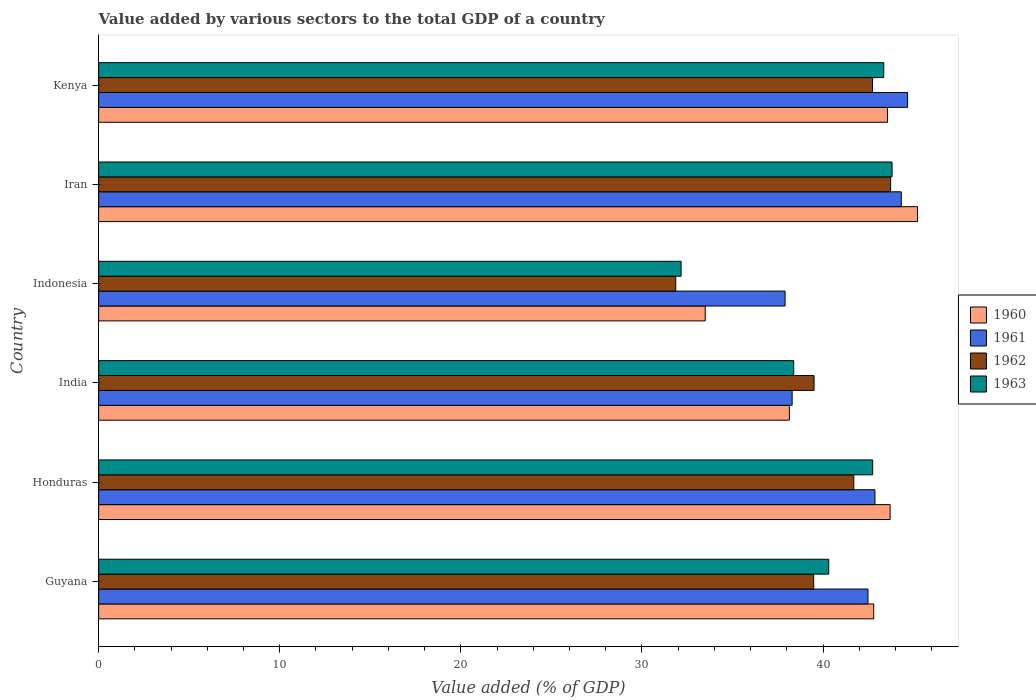How many different coloured bars are there?
Your answer should be very brief. 4. How many groups of bars are there?
Give a very brief answer. 6. Are the number of bars on each tick of the Y-axis equal?
Provide a short and direct response. Yes. How many bars are there on the 1st tick from the top?
Your answer should be compact. 4. How many bars are there on the 3rd tick from the bottom?
Your answer should be compact. 4. What is the label of the 4th group of bars from the top?
Your response must be concise. India. What is the value added by various sectors to the total GDP in 1961 in Iran?
Your response must be concise. 44.32. Across all countries, what is the maximum value added by various sectors to the total GDP in 1963?
Your response must be concise. 43.81. Across all countries, what is the minimum value added by various sectors to the total GDP in 1960?
Offer a terse response. 33.5. In which country was the value added by various sectors to the total GDP in 1960 maximum?
Make the answer very short. Iran. In which country was the value added by various sectors to the total GDP in 1961 minimum?
Provide a short and direct response. Indonesia. What is the total value added by various sectors to the total GDP in 1963 in the graph?
Give a very brief answer. 240.76. What is the difference between the value added by various sectors to the total GDP in 1963 in India and that in Indonesia?
Your answer should be compact. 6.22. What is the difference between the value added by various sectors to the total GDP in 1960 in Kenya and the value added by various sectors to the total GDP in 1963 in Indonesia?
Make the answer very short. 11.4. What is the average value added by various sectors to the total GDP in 1962 per country?
Ensure brevity in your answer.  39.84. What is the difference between the value added by various sectors to the total GDP in 1962 and value added by various sectors to the total GDP in 1960 in Iran?
Provide a succinct answer. -1.48. What is the ratio of the value added by various sectors to the total GDP in 1963 in Guyana to that in Kenya?
Offer a very short reply. 0.93. Is the difference between the value added by various sectors to the total GDP in 1962 in Guyana and Kenya greater than the difference between the value added by various sectors to the total GDP in 1960 in Guyana and Kenya?
Provide a short and direct response. No. What is the difference between the highest and the second highest value added by various sectors to the total GDP in 1961?
Offer a very short reply. 0.35. What is the difference between the highest and the lowest value added by various sectors to the total GDP in 1960?
Your answer should be very brief. 11.72. Is the sum of the value added by various sectors to the total GDP in 1962 in Guyana and Honduras greater than the maximum value added by various sectors to the total GDP in 1960 across all countries?
Your response must be concise. Yes. Is it the case that in every country, the sum of the value added by various sectors to the total GDP in 1961 and value added by various sectors to the total GDP in 1962 is greater than the sum of value added by various sectors to the total GDP in 1963 and value added by various sectors to the total GDP in 1960?
Give a very brief answer. No. What does the 2nd bar from the top in India represents?
Provide a succinct answer. 1962. How many bars are there?
Make the answer very short. 24. Are all the bars in the graph horizontal?
Offer a very short reply. Yes. How many countries are there in the graph?
Offer a terse response. 6. What is the difference between two consecutive major ticks on the X-axis?
Your answer should be compact. 10. Does the graph contain any zero values?
Ensure brevity in your answer.  No. Does the graph contain grids?
Provide a succinct answer. No. How many legend labels are there?
Provide a short and direct response. 4. What is the title of the graph?
Make the answer very short. Value added by various sectors to the total GDP of a country. Does "2004" appear as one of the legend labels in the graph?
Offer a terse response. No. What is the label or title of the X-axis?
Ensure brevity in your answer.  Value added (% of GDP). What is the label or title of the Y-axis?
Your answer should be very brief. Country. What is the Value added (% of GDP) in 1960 in Guyana?
Ensure brevity in your answer.  42.8. What is the Value added (% of GDP) in 1961 in Guyana?
Provide a short and direct response. 42.48. What is the Value added (% of GDP) in 1962 in Guyana?
Make the answer very short. 39.48. What is the Value added (% of GDP) in 1963 in Guyana?
Ensure brevity in your answer.  40.31. What is the Value added (% of GDP) in 1960 in Honduras?
Make the answer very short. 43.7. What is the Value added (% of GDP) in 1961 in Honduras?
Keep it short and to the point. 42.86. What is the Value added (% of GDP) of 1962 in Honduras?
Keep it short and to the point. 41.7. What is the Value added (% of GDP) in 1963 in Honduras?
Give a very brief answer. 42.74. What is the Value added (% of GDP) in 1960 in India?
Your answer should be very brief. 38.14. What is the Value added (% of GDP) in 1961 in India?
Make the answer very short. 38.29. What is the Value added (% of GDP) in 1962 in India?
Make the answer very short. 39.5. What is the Value added (% of GDP) in 1963 in India?
Provide a succinct answer. 38.38. What is the Value added (% of GDP) of 1960 in Indonesia?
Ensure brevity in your answer.  33.5. What is the Value added (% of GDP) of 1961 in Indonesia?
Your response must be concise. 37.9. What is the Value added (% of GDP) in 1962 in Indonesia?
Your answer should be compact. 31.87. What is the Value added (% of GDP) of 1963 in Indonesia?
Keep it short and to the point. 32.16. What is the Value added (% of GDP) of 1960 in Iran?
Your answer should be very brief. 45.21. What is the Value added (% of GDP) of 1961 in Iran?
Your answer should be very brief. 44.32. What is the Value added (% of GDP) in 1962 in Iran?
Make the answer very short. 43.73. What is the Value added (% of GDP) of 1963 in Iran?
Provide a succinct answer. 43.81. What is the Value added (% of GDP) of 1960 in Kenya?
Provide a short and direct response. 43.56. What is the Value added (% of GDP) of 1961 in Kenya?
Give a very brief answer. 44.67. What is the Value added (% of GDP) of 1962 in Kenya?
Keep it short and to the point. 42.73. What is the Value added (% of GDP) of 1963 in Kenya?
Your answer should be very brief. 43.35. Across all countries, what is the maximum Value added (% of GDP) in 1960?
Keep it short and to the point. 45.21. Across all countries, what is the maximum Value added (% of GDP) in 1961?
Your answer should be compact. 44.67. Across all countries, what is the maximum Value added (% of GDP) of 1962?
Offer a terse response. 43.73. Across all countries, what is the maximum Value added (% of GDP) in 1963?
Offer a very short reply. 43.81. Across all countries, what is the minimum Value added (% of GDP) in 1960?
Offer a very short reply. 33.5. Across all countries, what is the minimum Value added (% of GDP) in 1961?
Offer a terse response. 37.9. Across all countries, what is the minimum Value added (% of GDP) of 1962?
Your answer should be very brief. 31.87. Across all countries, what is the minimum Value added (% of GDP) of 1963?
Make the answer very short. 32.16. What is the total Value added (% of GDP) of 1960 in the graph?
Your response must be concise. 246.91. What is the total Value added (% of GDP) of 1961 in the graph?
Give a very brief answer. 250.53. What is the total Value added (% of GDP) in 1962 in the graph?
Provide a succinct answer. 239.01. What is the total Value added (% of GDP) in 1963 in the graph?
Ensure brevity in your answer.  240.76. What is the difference between the Value added (% of GDP) of 1960 in Guyana and that in Honduras?
Give a very brief answer. -0.91. What is the difference between the Value added (% of GDP) of 1961 in Guyana and that in Honduras?
Ensure brevity in your answer.  -0.38. What is the difference between the Value added (% of GDP) of 1962 in Guyana and that in Honduras?
Your response must be concise. -2.21. What is the difference between the Value added (% of GDP) of 1963 in Guyana and that in Honduras?
Your answer should be compact. -2.43. What is the difference between the Value added (% of GDP) in 1960 in Guyana and that in India?
Provide a succinct answer. 4.66. What is the difference between the Value added (% of GDP) in 1961 in Guyana and that in India?
Ensure brevity in your answer.  4.19. What is the difference between the Value added (% of GDP) of 1962 in Guyana and that in India?
Give a very brief answer. -0.02. What is the difference between the Value added (% of GDP) of 1963 in Guyana and that in India?
Make the answer very short. 1.93. What is the difference between the Value added (% of GDP) in 1960 in Guyana and that in Indonesia?
Your answer should be very brief. 9.3. What is the difference between the Value added (% of GDP) of 1961 in Guyana and that in Indonesia?
Give a very brief answer. 4.58. What is the difference between the Value added (% of GDP) of 1962 in Guyana and that in Indonesia?
Make the answer very short. 7.62. What is the difference between the Value added (% of GDP) in 1963 in Guyana and that in Indonesia?
Offer a very short reply. 8.15. What is the difference between the Value added (% of GDP) of 1960 in Guyana and that in Iran?
Make the answer very short. -2.42. What is the difference between the Value added (% of GDP) of 1961 in Guyana and that in Iran?
Offer a terse response. -1.84. What is the difference between the Value added (% of GDP) of 1962 in Guyana and that in Iran?
Your answer should be very brief. -4.25. What is the difference between the Value added (% of GDP) of 1963 in Guyana and that in Iran?
Provide a short and direct response. -3.5. What is the difference between the Value added (% of GDP) in 1960 in Guyana and that in Kenya?
Provide a succinct answer. -0.76. What is the difference between the Value added (% of GDP) in 1961 in Guyana and that in Kenya?
Provide a short and direct response. -2.19. What is the difference between the Value added (% of GDP) in 1962 in Guyana and that in Kenya?
Your answer should be very brief. -3.25. What is the difference between the Value added (% of GDP) of 1963 in Guyana and that in Kenya?
Offer a very short reply. -3.04. What is the difference between the Value added (% of GDP) of 1960 in Honduras and that in India?
Offer a very short reply. 5.57. What is the difference between the Value added (% of GDP) of 1961 in Honduras and that in India?
Provide a succinct answer. 4.57. What is the difference between the Value added (% of GDP) of 1962 in Honduras and that in India?
Your response must be concise. 2.19. What is the difference between the Value added (% of GDP) of 1963 in Honduras and that in India?
Provide a succinct answer. 4.36. What is the difference between the Value added (% of GDP) in 1960 in Honduras and that in Indonesia?
Keep it short and to the point. 10.21. What is the difference between the Value added (% of GDP) in 1961 in Honduras and that in Indonesia?
Ensure brevity in your answer.  4.96. What is the difference between the Value added (% of GDP) in 1962 in Honduras and that in Indonesia?
Make the answer very short. 9.83. What is the difference between the Value added (% of GDP) of 1963 in Honduras and that in Indonesia?
Offer a terse response. 10.58. What is the difference between the Value added (% of GDP) in 1960 in Honduras and that in Iran?
Offer a very short reply. -1.51. What is the difference between the Value added (% of GDP) of 1961 in Honduras and that in Iran?
Offer a terse response. -1.46. What is the difference between the Value added (% of GDP) of 1962 in Honduras and that in Iran?
Your answer should be compact. -2.03. What is the difference between the Value added (% of GDP) in 1963 in Honduras and that in Iran?
Your answer should be compact. -1.07. What is the difference between the Value added (% of GDP) of 1960 in Honduras and that in Kenya?
Provide a succinct answer. 0.15. What is the difference between the Value added (% of GDP) of 1961 in Honduras and that in Kenya?
Your answer should be very brief. -1.8. What is the difference between the Value added (% of GDP) of 1962 in Honduras and that in Kenya?
Provide a short and direct response. -1.03. What is the difference between the Value added (% of GDP) in 1963 in Honduras and that in Kenya?
Your answer should be compact. -0.61. What is the difference between the Value added (% of GDP) in 1960 in India and that in Indonesia?
Your answer should be very brief. 4.64. What is the difference between the Value added (% of GDP) in 1961 in India and that in Indonesia?
Make the answer very short. 0.39. What is the difference between the Value added (% of GDP) of 1962 in India and that in Indonesia?
Make the answer very short. 7.64. What is the difference between the Value added (% of GDP) of 1963 in India and that in Indonesia?
Your response must be concise. 6.22. What is the difference between the Value added (% of GDP) in 1960 in India and that in Iran?
Your answer should be very brief. -7.08. What is the difference between the Value added (% of GDP) of 1961 in India and that in Iran?
Provide a short and direct response. -6.03. What is the difference between the Value added (% of GDP) of 1962 in India and that in Iran?
Keep it short and to the point. -4.23. What is the difference between the Value added (% of GDP) in 1963 in India and that in Iran?
Offer a terse response. -5.43. What is the difference between the Value added (% of GDP) in 1960 in India and that in Kenya?
Ensure brevity in your answer.  -5.42. What is the difference between the Value added (% of GDP) in 1961 in India and that in Kenya?
Keep it short and to the point. -6.37. What is the difference between the Value added (% of GDP) of 1962 in India and that in Kenya?
Keep it short and to the point. -3.23. What is the difference between the Value added (% of GDP) in 1963 in India and that in Kenya?
Provide a succinct answer. -4.97. What is the difference between the Value added (% of GDP) of 1960 in Indonesia and that in Iran?
Provide a short and direct response. -11.72. What is the difference between the Value added (% of GDP) in 1961 in Indonesia and that in Iran?
Your answer should be compact. -6.42. What is the difference between the Value added (% of GDP) in 1962 in Indonesia and that in Iran?
Provide a succinct answer. -11.86. What is the difference between the Value added (% of GDP) in 1963 in Indonesia and that in Iran?
Your answer should be compact. -11.65. What is the difference between the Value added (% of GDP) in 1960 in Indonesia and that in Kenya?
Ensure brevity in your answer.  -10.06. What is the difference between the Value added (% of GDP) in 1961 in Indonesia and that in Kenya?
Make the answer very short. -6.76. What is the difference between the Value added (% of GDP) in 1962 in Indonesia and that in Kenya?
Offer a terse response. -10.87. What is the difference between the Value added (% of GDP) of 1963 in Indonesia and that in Kenya?
Keep it short and to the point. -11.19. What is the difference between the Value added (% of GDP) in 1960 in Iran and that in Kenya?
Ensure brevity in your answer.  1.65. What is the difference between the Value added (% of GDP) of 1961 in Iran and that in Kenya?
Provide a succinct answer. -0.35. What is the difference between the Value added (% of GDP) of 1962 in Iran and that in Kenya?
Ensure brevity in your answer.  1. What is the difference between the Value added (% of GDP) of 1963 in Iran and that in Kenya?
Your answer should be very brief. 0.46. What is the difference between the Value added (% of GDP) of 1960 in Guyana and the Value added (% of GDP) of 1961 in Honduras?
Your response must be concise. -0.07. What is the difference between the Value added (% of GDP) of 1960 in Guyana and the Value added (% of GDP) of 1962 in Honduras?
Ensure brevity in your answer.  1.1. What is the difference between the Value added (% of GDP) of 1960 in Guyana and the Value added (% of GDP) of 1963 in Honduras?
Provide a succinct answer. 0.06. What is the difference between the Value added (% of GDP) in 1961 in Guyana and the Value added (% of GDP) in 1962 in Honduras?
Your answer should be compact. 0.78. What is the difference between the Value added (% of GDP) of 1961 in Guyana and the Value added (% of GDP) of 1963 in Honduras?
Ensure brevity in your answer.  -0.26. What is the difference between the Value added (% of GDP) of 1962 in Guyana and the Value added (% of GDP) of 1963 in Honduras?
Give a very brief answer. -3.26. What is the difference between the Value added (% of GDP) in 1960 in Guyana and the Value added (% of GDP) in 1961 in India?
Your answer should be very brief. 4.5. What is the difference between the Value added (% of GDP) in 1960 in Guyana and the Value added (% of GDP) in 1962 in India?
Offer a very short reply. 3.29. What is the difference between the Value added (% of GDP) of 1960 in Guyana and the Value added (% of GDP) of 1963 in India?
Make the answer very short. 4.42. What is the difference between the Value added (% of GDP) in 1961 in Guyana and the Value added (% of GDP) in 1962 in India?
Your answer should be compact. 2.98. What is the difference between the Value added (% of GDP) in 1961 in Guyana and the Value added (% of GDP) in 1963 in India?
Your answer should be very brief. 4.1. What is the difference between the Value added (% of GDP) in 1962 in Guyana and the Value added (% of GDP) in 1963 in India?
Make the answer very short. 1.1. What is the difference between the Value added (% of GDP) of 1960 in Guyana and the Value added (% of GDP) of 1961 in Indonesia?
Give a very brief answer. 4.89. What is the difference between the Value added (% of GDP) of 1960 in Guyana and the Value added (% of GDP) of 1962 in Indonesia?
Make the answer very short. 10.93. What is the difference between the Value added (% of GDP) in 1960 in Guyana and the Value added (% of GDP) in 1963 in Indonesia?
Your answer should be very brief. 10.64. What is the difference between the Value added (% of GDP) in 1961 in Guyana and the Value added (% of GDP) in 1962 in Indonesia?
Your answer should be compact. 10.61. What is the difference between the Value added (% of GDP) in 1961 in Guyana and the Value added (% of GDP) in 1963 in Indonesia?
Your response must be concise. 10.32. What is the difference between the Value added (% of GDP) in 1962 in Guyana and the Value added (% of GDP) in 1963 in Indonesia?
Your answer should be compact. 7.32. What is the difference between the Value added (% of GDP) of 1960 in Guyana and the Value added (% of GDP) of 1961 in Iran?
Keep it short and to the point. -1.52. What is the difference between the Value added (% of GDP) in 1960 in Guyana and the Value added (% of GDP) in 1962 in Iran?
Give a very brief answer. -0.93. What is the difference between the Value added (% of GDP) of 1960 in Guyana and the Value added (% of GDP) of 1963 in Iran?
Provide a succinct answer. -1.01. What is the difference between the Value added (% of GDP) of 1961 in Guyana and the Value added (% of GDP) of 1962 in Iran?
Make the answer very short. -1.25. What is the difference between the Value added (% of GDP) of 1961 in Guyana and the Value added (% of GDP) of 1963 in Iran?
Offer a very short reply. -1.33. What is the difference between the Value added (% of GDP) in 1962 in Guyana and the Value added (% of GDP) in 1963 in Iran?
Make the answer very short. -4.33. What is the difference between the Value added (% of GDP) of 1960 in Guyana and the Value added (% of GDP) of 1961 in Kenya?
Your answer should be very brief. -1.87. What is the difference between the Value added (% of GDP) in 1960 in Guyana and the Value added (% of GDP) in 1962 in Kenya?
Provide a short and direct response. 0.07. What is the difference between the Value added (% of GDP) of 1960 in Guyana and the Value added (% of GDP) of 1963 in Kenya?
Ensure brevity in your answer.  -0.55. What is the difference between the Value added (% of GDP) in 1961 in Guyana and the Value added (% of GDP) in 1962 in Kenya?
Provide a succinct answer. -0.25. What is the difference between the Value added (% of GDP) of 1961 in Guyana and the Value added (% of GDP) of 1963 in Kenya?
Your answer should be very brief. -0.87. What is the difference between the Value added (% of GDP) in 1962 in Guyana and the Value added (% of GDP) in 1963 in Kenya?
Your answer should be very brief. -3.87. What is the difference between the Value added (% of GDP) of 1960 in Honduras and the Value added (% of GDP) of 1961 in India?
Keep it short and to the point. 5.41. What is the difference between the Value added (% of GDP) of 1960 in Honduras and the Value added (% of GDP) of 1962 in India?
Offer a terse response. 4.2. What is the difference between the Value added (% of GDP) in 1960 in Honduras and the Value added (% of GDP) in 1963 in India?
Your answer should be very brief. 5.32. What is the difference between the Value added (% of GDP) of 1961 in Honduras and the Value added (% of GDP) of 1962 in India?
Make the answer very short. 3.36. What is the difference between the Value added (% of GDP) of 1961 in Honduras and the Value added (% of GDP) of 1963 in India?
Your response must be concise. 4.48. What is the difference between the Value added (% of GDP) in 1962 in Honduras and the Value added (% of GDP) in 1963 in India?
Provide a short and direct response. 3.32. What is the difference between the Value added (% of GDP) in 1960 in Honduras and the Value added (% of GDP) in 1961 in Indonesia?
Your response must be concise. 5.8. What is the difference between the Value added (% of GDP) of 1960 in Honduras and the Value added (% of GDP) of 1962 in Indonesia?
Your answer should be compact. 11.84. What is the difference between the Value added (% of GDP) in 1960 in Honduras and the Value added (% of GDP) in 1963 in Indonesia?
Your answer should be very brief. 11.54. What is the difference between the Value added (% of GDP) of 1961 in Honduras and the Value added (% of GDP) of 1962 in Indonesia?
Your response must be concise. 11. What is the difference between the Value added (% of GDP) in 1961 in Honduras and the Value added (% of GDP) in 1963 in Indonesia?
Offer a terse response. 10.7. What is the difference between the Value added (% of GDP) of 1962 in Honduras and the Value added (% of GDP) of 1963 in Indonesia?
Ensure brevity in your answer.  9.54. What is the difference between the Value added (% of GDP) in 1960 in Honduras and the Value added (% of GDP) in 1961 in Iran?
Make the answer very short. -0.62. What is the difference between the Value added (% of GDP) in 1960 in Honduras and the Value added (% of GDP) in 1962 in Iran?
Provide a short and direct response. -0.03. What is the difference between the Value added (% of GDP) of 1960 in Honduras and the Value added (% of GDP) of 1963 in Iran?
Your answer should be compact. -0.11. What is the difference between the Value added (% of GDP) in 1961 in Honduras and the Value added (% of GDP) in 1962 in Iran?
Give a very brief answer. -0.87. What is the difference between the Value added (% of GDP) in 1961 in Honduras and the Value added (% of GDP) in 1963 in Iran?
Your answer should be very brief. -0.95. What is the difference between the Value added (% of GDP) in 1962 in Honduras and the Value added (% of GDP) in 1963 in Iran?
Offer a very short reply. -2.11. What is the difference between the Value added (% of GDP) in 1960 in Honduras and the Value added (% of GDP) in 1961 in Kenya?
Ensure brevity in your answer.  -0.96. What is the difference between the Value added (% of GDP) of 1960 in Honduras and the Value added (% of GDP) of 1962 in Kenya?
Ensure brevity in your answer.  0.97. What is the difference between the Value added (% of GDP) in 1960 in Honduras and the Value added (% of GDP) in 1963 in Kenya?
Your answer should be very brief. 0.35. What is the difference between the Value added (% of GDP) of 1961 in Honduras and the Value added (% of GDP) of 1962 in Kenya?
Your answer should be very brief. 0.13. What is the difference between the Value added (% of GDP) of 1961 in Honduras and the Value added (% of GDP) of 1963 in Kenya?
Offer a very short reply. -0.49. What is the difference between the Value added (% of GDP) in 1962 in Honduras and the Value added (% of GDP) in 1963 in Kenya?
Provide a succinct answer. -1.65. What is the difference between the Value added (% of GDP) of 1960 in India and the Value added (% of GDP) of 1961 in Indonesia?
Your answer should be very brief. 0.24. What is the difference between the Value added (% of GDP) in 1960 in India and the Value added (% of GDP) in 1962 in Indonesia?
Your answer should be compact. 6.27. What is the difference between the Value added (% of GDP) of 1960 in India and the Value added (% of GDP) of 1963 in Indonesia?
Your response must be concise. 5.98. What is the difference between the Value added (% of GDP) of 1961 in India and the Value added (% of GDP) of 1962 in Indonesia?
Offer a very short reply. 6.43. What is the difference between the Value added (% of GDP) of 1961 in India and the Value added (% of GDP) of 1963 in Indonesia?
Offer a terse response. 6.13. What is the difference between the Value added (% of GDP) of 1962 in India and the Value added (% of GDP) of 1963 in Indonesia?
Give a very brief answer. 7.34. What is the difference between the Value added (% of GDP) of 1960 in India and the Value added (% of GDP) of 1961 in Iran?
Ensure brevity in your answer.  -6.18. What is the difference between the Value added (% of GDP) of 1960 in India and the Value added (% of GDP) of 1962 in Iran?
Provide a short and direct response. -5.59. What is the difference between the Value added (% of GDP) of 1960 in India and the Value added (% of GDP) of 1963 in Iran?
Provide a succinct answer. -5.67. What is the difference between the Value added (% of GDP) of 1961 in India and the Value added (% of GDP) of 1962 in Iran?
Keep it short and to the point. -5.44. What is the difference between the Value added (% of GDP) in 1961 in India and the Value added (% of GDP) in 1963 in Iran?
Provide a succinct answer. -5.52. What is the difference between the Value added (% of GDP) of 1962 in India and the Value added (% of GDP) of 1963 in Iran?
Give a very brief answer. -4.31. What is the difference between the Value added (% of GDP) in 1960 in India and the Value added (% of GDP) in 1961 in Kenya?
Provide a short and direct response. -6.53. What is the difference between the Value added (% of GDP) in 1960 in India and the Value added (% of GDP) in 1962 in Kenya?
Make the answer very short. -4.59. What is the difference between the Value added (% of GDP) in 1960 in India and the Value added (% of GDP) in 1963 in Kenya?
Make the answer very short. -5.21. What is the difference between the Value added (% of GDP) in 1961 in India and the Value added (% of GDP) in 1962 in Kenya?
Offer a terse response. -4.44. What is the difference between the Value added (% of GDP) in 1961 in India and the Value added (% of GDP) in 1963 in Kenya?
Keep it short and to the point. -5.06. What is the difference between the Value added (% of GDP) in 1962 in India and the Value added (% of GDP) in 1963 in Kenya?
Your answer should be compact. -3.85. What is the difference between the Value added (% of GDP) of 1960 in Indonesia and the Value added (% of GDP) of 1961 in Iran?
Offer a very short reply. -10.82. What is the difference between the Value added (% of GDP) in 1960 in Indonesia and the Value added (% of GDP) in 1962 in Iran?
Your answer should be compact. -10.24. What is the difference between the Value added (% of GDP) of 1960 in Indonesia and the Value added (% of GDP) of 1963 in Iran?
Provide a short and direct response. -10.32. What is the difference between the Value added (% of GDP) in 1961 in Indonesia and the Value added (% of GDP) in 1962 in Iran?
Provide a succinct answer. -5.83. What is the difference between the Value added (% of GDP) in 1961 in Indonesia and the Value added (% of GDP) in 1963 in Iran?
Your response must be concise. -5.91. What is the difference between the Value added (% of GDP) in 1962 in Indonesia and the Value added (% of GDP) in 1963 in Iran?
Your answer should be very brief. -11.94. What is the difference between the Value added (% of GDP) of 1960 in Indonesia and the Value added (% of GDP) of 1961 in Kenya?
Your answer should be compact. -11.17. What is the difference between the Value added (% of GDP) of 1960 in Indonesia and the Value added (% of GDP) of 1962 in Kenya?
Offer a terse response. -9.24. What is the difference between the Value added (% of GDP) in 1960 in Indonesia and the Value added (% of GDP) in 1963 in Kenya?
Offer a terse response. -9.86. What is the difference between the Value added (% of GDP) in 1961 in Indonesia and the Value added (% of GDP) in 1962 in Kenya?
Your response must be concise. -4.83. What is the difference between the Value added (% of GDP) of 1961 in Indonesia and the Value added (% of GDP) of 1963 in Kenya?
Make the answer very short. -5.45. What is the difference between the Value added (% of GDP) of 1962 in Indonesia and the Value added (% of GDP) of 1963 in Kenya?
Offer a terse response. -11.48. What is the difference between the Value added (% of GDP) of 1960 in Iran and the Value added (% of GDP) of 1961 in Kenya?
Make the answer very short. 0.55. What is the difference between the Value added (% of GDP) of 1960 in Iran and the Value added (% of GDP) of 1962 in Kenya?
Give a very brief answer. 2.48. What is the difference between the Value added (% of GDP) in 1960 in Iran and the Value added (% of GDP) in 1963 in Kenya?
Keep it short and to the point. 1.86. What is the difference between the Value added (% of GDP) of 1961 in Iran and the Value added (% of GDP) of 1962 in Kenya?
Your response must be concise. 1.59. What is the difference between the Value added (% of GDP) of 1961 in Iran and the Value added (% of GDP) of 1963 in Kenya?
Your answer should be very brief. 0.97. What is the difference between the Value added (% of GDP) of 1962 in Iran and the Value added (% of GDP) of 1963 in Kenya?
Your response must be concise. 0.38. What is the average Value added (% of GDP) in 1960 per country?
Keep it short and to the point. 41.15. What is the average Value added (% of GDP) of 1961 per country?
Offer a very short reply. 41.75. What is the average Value added (% of GDP) in 1962 per country?
Make the answer very short. 39.84. What is the average Value added (% of GDP) in 1963 per country?
Your answer should be very brief. 40.13. What is the difference between the Value added (% of GDP) of 1960 and Value added (% of GDP) of 1961 in Guyana?
Ensure brevity in your answer.  0.32. What is the difference between the Value added (% of GDP) of 1960 and Value added (% of GDP) of 1962 in Guyana?
Make the answer very short. 3.31. What is the difference between the Value added (% of GDP) in 1960 and Value added (% of GDP) in 1963 in Guyana?
Ensure brevity in your answer.  2.48. What is the difference between the Value added (% of GDP) of 1961 and Value added (% of GDP) of 1962 in Guyana?
Give a very brief answer. 3. What is the difference between the Value added (% of GDP) of 1961 and Value added (% of GDP) of 1963 in Guyana?
Make the answer very short. 2.17. What is the difference between the Value added (% of GDP) of 1962 and Value added (% of GDP) of 1963 in Guyana?
Offer a very short reply. -0.83. What is the difference between the Value added (% of GDP) in 1960 and Value added (% of GDP) in 1961 in Honduras?
Offer a terse response. 0.84. What is the difference between the Value added (% of GDP) in 1960 and Value added (% of GDP) in 1962 in Honduras?
Your answer should be compact. 2.01. What is the difference between the Value added (% of GDP) of 1960 and Value added (% of GDP) of 1963 in Honduras?
Keep it short and to the point. 0.96. What is the difference between the Value added (% of GDP) of 1961 and Value added (% of GDP) of 1962 in Honduras?
Ensure brevity in your answer.  1.17. What is the difference between the Value added (% of GDP) in 1961 and Value added (% of GDP) in 1963 in Honduras?
Provide a short and direct response. 0.12. What is the difference between the Value added (% of GDP) of 1962 and Value added (% of GDP) of 1963 in Honduras?
Offer a very short reply. -1.04. What is the difference between the Value added (% of GDP) in 1960 and Value added (% of GDP) in 1961 in India?
Give a very brief answer. -0.15. What is the difference between the Value added (% of GDP) in 1960 and Value added (% of GDP) in 1962 in India?
Offer a very short reply. -1.36. What is the difference between the Value added (% of GDP) in 1960 and Value added (% of GDP) in 1963 in India?
Give a very brief answer. -0.24. What is the difference between the Value added (% of GDP) of 1961 and Value added (% of GDP) of 1962 in India?
Keep it short and to the point. -1.21. What is the difference between the Value added (% of GDP) of 1961 and Value added (% of GDP) of 1963 in India?
Your answer should be very brief. -0.09. What is the difference between the Value added (% of GDP) in 1962 and Value added (% of GDP) in 1963 in India?
Offer a very short reply. 1.12. What is the difference between the Value added (% of GDP) of 1960 and Value added (% of GDP) of 1961 in Indonesia?
Your answer should be very brief. -4.41. What is the difference between the Value added (% of GDP) in 1960 and Value added (% of GDP) in 1962 in Indonesia?
Provide a succinct answer. 1.63. What is the difference between the Value added (% of GDP) of 1961 and Value added (% of GDP) of 1962 in Indonesia?
Ensure brevity in your answer.  6.04. What is the difference between the Value added (% of GDP) in 1961 and Value added (% of GDP) in 1963 in Indonesia?
Give a very brief answer. 5.74. What is the difference between the Value added (% of GDP) in 1962 and Value added (% of GDP) in 1963 in Indonesia?
Offer a very short reply. -0.3. What is the difference between the Value added (% of GDP) of 1960 and Value added (% of GDP) of 1961 in Iran?
Offer a terse response. 0.89. What is the difference between the Value added (% of GDP) of 1960 and Value added (% of GDP) of 1962 in Iran?
Make the answer very short. 1.48. What is the difference between the Value added (% of GDP) of 1960 and Value added (% of GDP) of 1963 in Iran?
Your response must be concise. 1.4. What is the difference between the Value added (% of GDP) of 1961 and Value added (% of GDP) of 1962 in Iran?
Offer a very short reply. 0.59. What is the difference between the Value added (% of GDP) of 1961 and Value added (% of GDP) of 1963 in Iran?
Your answer should be very brief. 0.51. What is the difference between the Value added (% of GDP) in 1962 and Value added (% of GDP) in 1963 in Iran?
Your response must be concise. -0.08. What is the difference between the Value added (% of GDP) in 1960 and Value added (% of GDP) in 1961 in Kenya?
Offer a terse response. -1.11. What is the difference between the Value added (% of GDP) in 1960 and Value added (% of GDP) in 1962 in Kenya?
Your answer should be compact. 0.83. What is the difference between the Value added (% of GDP) of 1960 and Value added (% of GDP) of 1963 in Kenya?
Your response must be concise. 0.21. What is the difference between the Value added (% of GDP) in 1961 and Value added (% of GDP) in 1962 in Kenya?
Make the answer very short. 1.94. What is the difference between the Value added (% of GDP) of 1961 and Value added (% of GDP) of 1963 in Kenya?
Your response must be concise. 1.32. What is the difference between the Value added (% of GDP) of 1962 and Value added (% of GDP) of 1963 in Kenya?
Provide a short and direct response. -0.62. What is the ratio of the Value added (% of GDP) of 1960 in Guyana to that in Honduras?
Give a very brief answer. 0.98. What is the ratio of the Value added (% of GDP) of 1961 in Guyana to that in Honduras?
Keep it short and to the point. 0.99. What is the ratio of the Value added (% of GDP) in 1962 in Guyana to that in Honduras?
Make the answer very short. 0.95. What is the ratio of the Value added (% of GDP) of 1963 in Guyana to that in Honduras?
Keep it short and to the point. 0.94. What is the ratio of the Value added (% of GDP) in 1960 in Guyana to that in India?
Make the answer very short. 1.12. What is the ratio of the Value added (% of GDP) of 1961 in Guyana to that in India?
Your response must be concise. 1.11. What is the ratio of the Value added (% of GDP) in 1963 in Guyana to that in India?
Offer a terse response. 1.05. What is the ratio of the Value added (% of GDP) in 1960 in Guyana to that in Indonesia?
Make the answer very short. 1.28. What is the ratio of the Value added (% of GDP) in 1961 in Guyana to that in Indonesia?
Your answer should be very brief. 1.12. What is the ratio of the Value added (% of GDP) in 1962 in Guyana to that in Indonesia?
Make the answer very short. 1.24. What is the ratio of the Value added (% of GDP) in 1963 in Guyana to that in Indonesia?
Offer a terse response. 1.25. What is the ratio of the Value added (% of GDP) of 1960 in Guyana to that in Iran?
Offer a terse response. 0.95. What is the ratio of the Value added (% of GDP) in 1961 in Guyana to that in Iran?
Your answer should be compact. 0.96. What is the ratio of the Value added (% of GDP) of 1962 in Guyana to that in Iran?
Offer a terse response. 0.9. What is the ratio of the Value added (% of GDP) in 1963 in Guyana to that in Iran?
Your answer should be compact. 0.92. What is the ratio of the Value added (% of GDP) of 1960 in Guyana to that in Kenya?
Your response must be concise. 0.98. What is the ratio of the Value added (% of GDP) in 1961 in Guyana to that in Kenya?
Make the answer very short. 0.95. What is the ratio of the Value added (% of GDP) in 1962 in Guyana to that in Kenya?
Your response must be concise. 0.92. What is the ratio of the Value added (% of GDP) of 1960 in Honduras to that in India?
Make the answer very short. 1.15. What is the ratio of the Value added (% of GDP) in 1961 in Honduras to that in India?
Provide a short and direct response. 1.12. What is the ratio of the Value added (% of GDP) of 1962 in Honduras to that in India?
Offer a very short reply. 1.06. What is the ratio of the Value added (% of GDP) in 1963 in Honduras to that in India?
Provide a succinct answer. 1.11. What is the ratio of the Value added (% of GDP) of 1960 in Honduras to that in Indonesia?
Your response must be concise. 1.3. What is the ratio of the Value added (% of GDP) of 1961 in Honduras to that in Indonesia?
Your answer should be compact. 1.13. What is the ratio of the Value added (% of GDP) of 1962 in Honduras to that in Indonesia?
Offer a very short reply. 1.31. What is the ratio of the Value added (% of GDP) in 1963 in Honduras to that in Indonesia?
Make the answer very short. 1.33. What is the ratio of the Value added (% of GDP) in 1960 in Honduras to that in Iran?
Keep it short and to the point. 0.97. What is the ratio of the Value added (% of GDP) of 1961 in Honduras to that in Iran?
Your response must be concise. 0.97. What is the ratio of the Value added (% of GDP) in 1962 in Honduras to that in Iran?
Keep it short and to the point. 0.95. What is the ratio of the Value added (% of GDP) of 1963 in Honduras to that in Iran?
Your response must be concise. 0.98. What is the ratio of the Value added (% of GDP) of 1961 in Honduras to that in Kenya?
Keep it short and to the point. 0.96. What is the ratio of the Value added (% of GDP) of 1962 in Honduras to that in Kenya?
Provide a succinct answer. 0.98. What is the ratio of the Value added (% of GDP) in 1963 in Honduras to that in Kenya?
Your response must be concise. 0.99. What is the ratio of the Value added (% of GDP) of 1960 in India to that in Indonesia?
Offer a very short reply. 1.14. What is the ratio of the Value added (% of GDP) in 1961 in India to that in Indonesia?
Keep it short and to the point. 1.01. What is the ratio of the Value added (% of GDP) in 1962 in India to that in Indonesia?
Give a very brief answer. 1.24. What is the ratio of the Value added (% of GDP) of 1963 in India to that in Indonesia?
Keep it short and to the point. 1.19. What is the ratio of the Value added (% of GDP) in 1960 in India to that in Iran?
Ensure brevity in your answer.  0.84. What is the ratio of the Value added (% of GDP) in 1961 in India to that in Iran?
Your answer should be compact. 0.86. What is the ratio of the Value added (% of GDP) in 1962 in India to that in Iran?
Your answer should be compact. 0.9. What is the ratio of the Value added (% of GDP) of 1963 in India to that in Iran?
Your answer should be compact. 0.88. What is the ratio of the Value added (% of GDP) in 1960 in India to that in Kenya?
Offer a terse response. 0.88. What is the ratio of the Value added (% of GDP) of 1961 in India to that in Kenya?
Give a very brief answer. 0.86. What is the ratio of the Value added (% of GDP) of 1962 in India to that in Kenya?
Make the answer very short. 0.92. What is the ratio of the Value added (% of GDP) of 1963 in India to that in Kenya?
Give a very brief answer. 0.89. What is the ratio of the Value added (% of GDP) in 1960 in Indonesia to that in Iran?
Your answer should be compact. 0.74. What is the ratio of the Value added (% of GDP) of 1961 in Indonesia to that in Iran?
Give a very brief answer. 0.86. What is the ratio of the Value added (% of GDP) of 1962 in Indonesia to that in Iran?
Ensure brevity in your answer.  0.73. What is the ratio of the Value added (% of GDP) in 1963 in Indonesia to that in Iran?
Provide a succinct answer. 0.73. What is the ratio of the Value added (% of GDP) in 1960 in Indonesia to that in Kenya?
Make the answer very short. 0.77. What is the ratio of the Value added (% of GDP) in 1961 in Indonesia to that in Kenya?
Give a very brief answer. 0.85. What is the ratio of the Value added (% of GDP) of 1962 in Indonesia to that in Kenya?
Your response must be concise. 0.75. What is the ratio of the Value added (% of GDP) of 1963 in Indonesia to that in Kenya?
Keep it short and to the point. 0.74. What is the ratio of the Value added (% of GDP) of 1960 in Iran to that in Kenya?
Your answer should be very brief. 1.04. What is the ratio of the Value added (% of GDP) of 1962 in Iran to that in Kenya?
Your answer should be compact. 1.02. What is the ratio of the Value added (% of GDP) of 1963 in Iran to that in Kenya?
Your response must be concise. 1.01. What is the difference between the highest and the second highest Value added (% of GDP) of 1960?
Your response must be concise. 1.51. What is the difference between the highest and the second highest Value added (% of GDP) in 1961?
Ensure brevity in your answer.  0.35. What is the difference between the highest and the second highest Value added (% of GDP) of 1963?
Offer a very short reply. 0.46. What is the difference between the highest and the lowest Value added (% of GDP) of 1960?
Offer a very short reply. 11.72. What is the difference between the highest and the lowest Value added (% of GDP) of 1961?
Give a very brief answer. 6.76. What is the difference between the highest and the lowest Value added (% of GDP) in 1962?
Provide a succinct answer. 11.86. What is the difference between the highest and the lowest Value added (% of GDP) of 1963?
Your response must be concise. 11.65. 